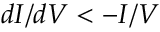Convert formula to latex. <formula><loc_0><loc_0><loc_500><loc_500>d I / d V < - I / V</formula> 